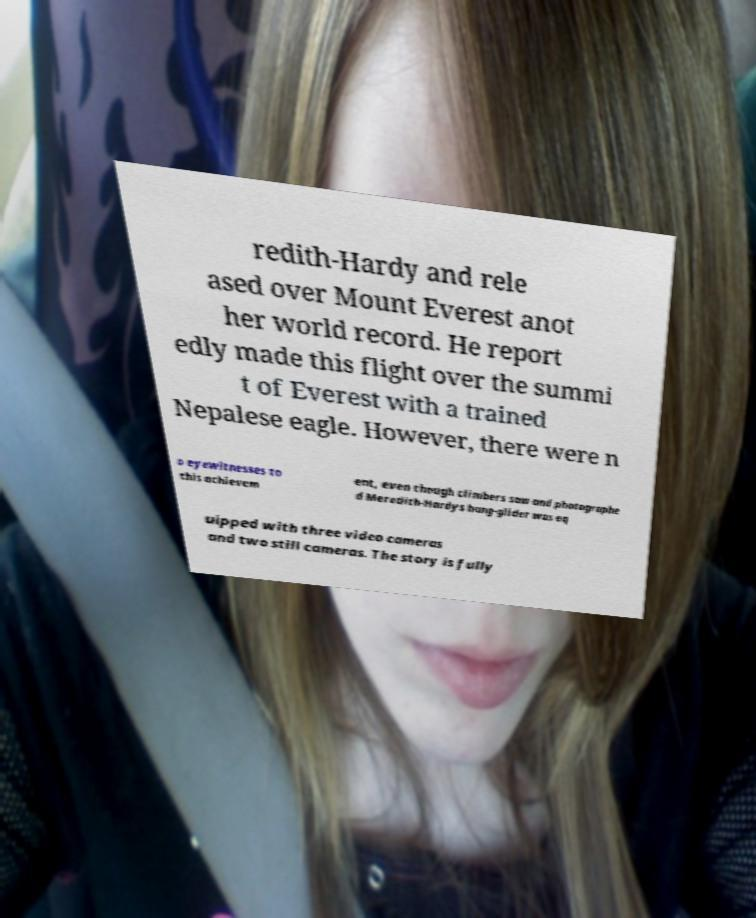Could you assist in decoding the text presented in this image and type it out clearly? redith-Hardy and rele ased over Mount Everest anot her world record. He report edly made this flight over the summi t of Everest with a trained Nepalese eagle. However, there were n o eyewitnesses to this achievem ent, even though climbers saw and photographe d Meredith-Hardys hang-glider was eq uipped with three video cameras and two still cameras. The story is fully 